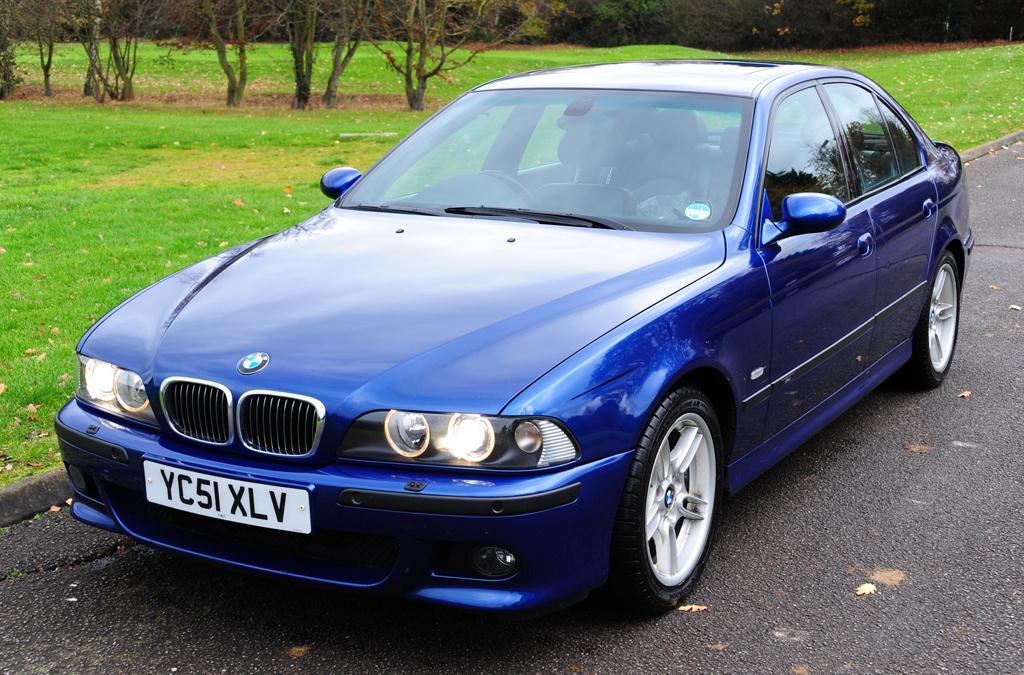Could you give a brief overview of what you see in this image? In this picture we can see a car on the road. We can see some grass and a few leaves on the ground. There are a few plants visible in the background. 